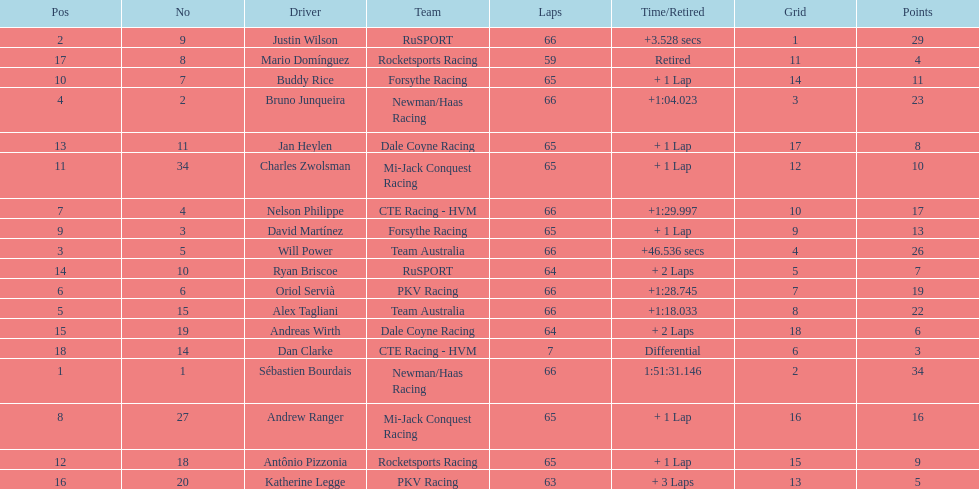How many points did first place receive? 34. How many did last place receive? 3. Who was the recipient of these last place points? Dan Clarke. 